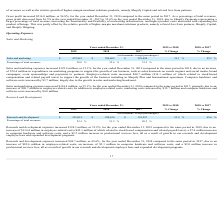According to Shopify's financial document, How much is the research and development expenses for the year ended 2019? According to the financial document, $ 355,015 (in thousands). The relevant text states: "Research and development $ 355,015 $ 230,674 $ 135,997 53.9 % 69.6 %..." Also, How much is the research and development expenses for the year ended 2018? According to the financial document, $ 230,674 (in thousands). The relevant text states: "Research and development $ 355,015 $ 230,674 $ 135,997 53.9 % 69.6 %..." Also, How much is the research and development expenses for the year ended 2017? According to the financial document, $ 135,997 (in thousands). The relevant text states: "Research and development $ 355,015 $ 230,674 $ 135,997 53.9 % 69.6 %..." Also, can you calculate: What is the average research and development expenses for 2018 and 2019? To answer this question, I need to perform calculations using the financial data. The calculation is: (355,015+230,674)/2, which equals 292844.5 (in thousands). This is based on the information: "Research and development $ 355,015 $ 230,674 $ 135,997 53.9 % 69.6 % Research and development $ 355,015 $ 230,674 $ 135,997 53.9 % 69.6 %..." The key data points involved are: 230,674, 355,015. Also, can you calculate: What is the average research and development expenses for 2017 and 2018? To answer this question, I need to perform calculations using the financial data. The calculation is: (230,674+135,997)/2, which equals 183335.5 (in thousands). This is based on the information: "Research and development $ 355,015 $ 230,674 $ 135,997 53.9 % 69.6 % Research and development $ 355,015 $ 230,674 $ 135,997 53.9 % 69.6 %..." The key data points involved are: 135,997, 230,674. Additionally, Between year ended 2018 and 2019, which year had higher research and development expenses? According to the financial document, 2019. The relevant text states: "Years ended December 31, 2019 vs 2018 2018 vs 2017..." 